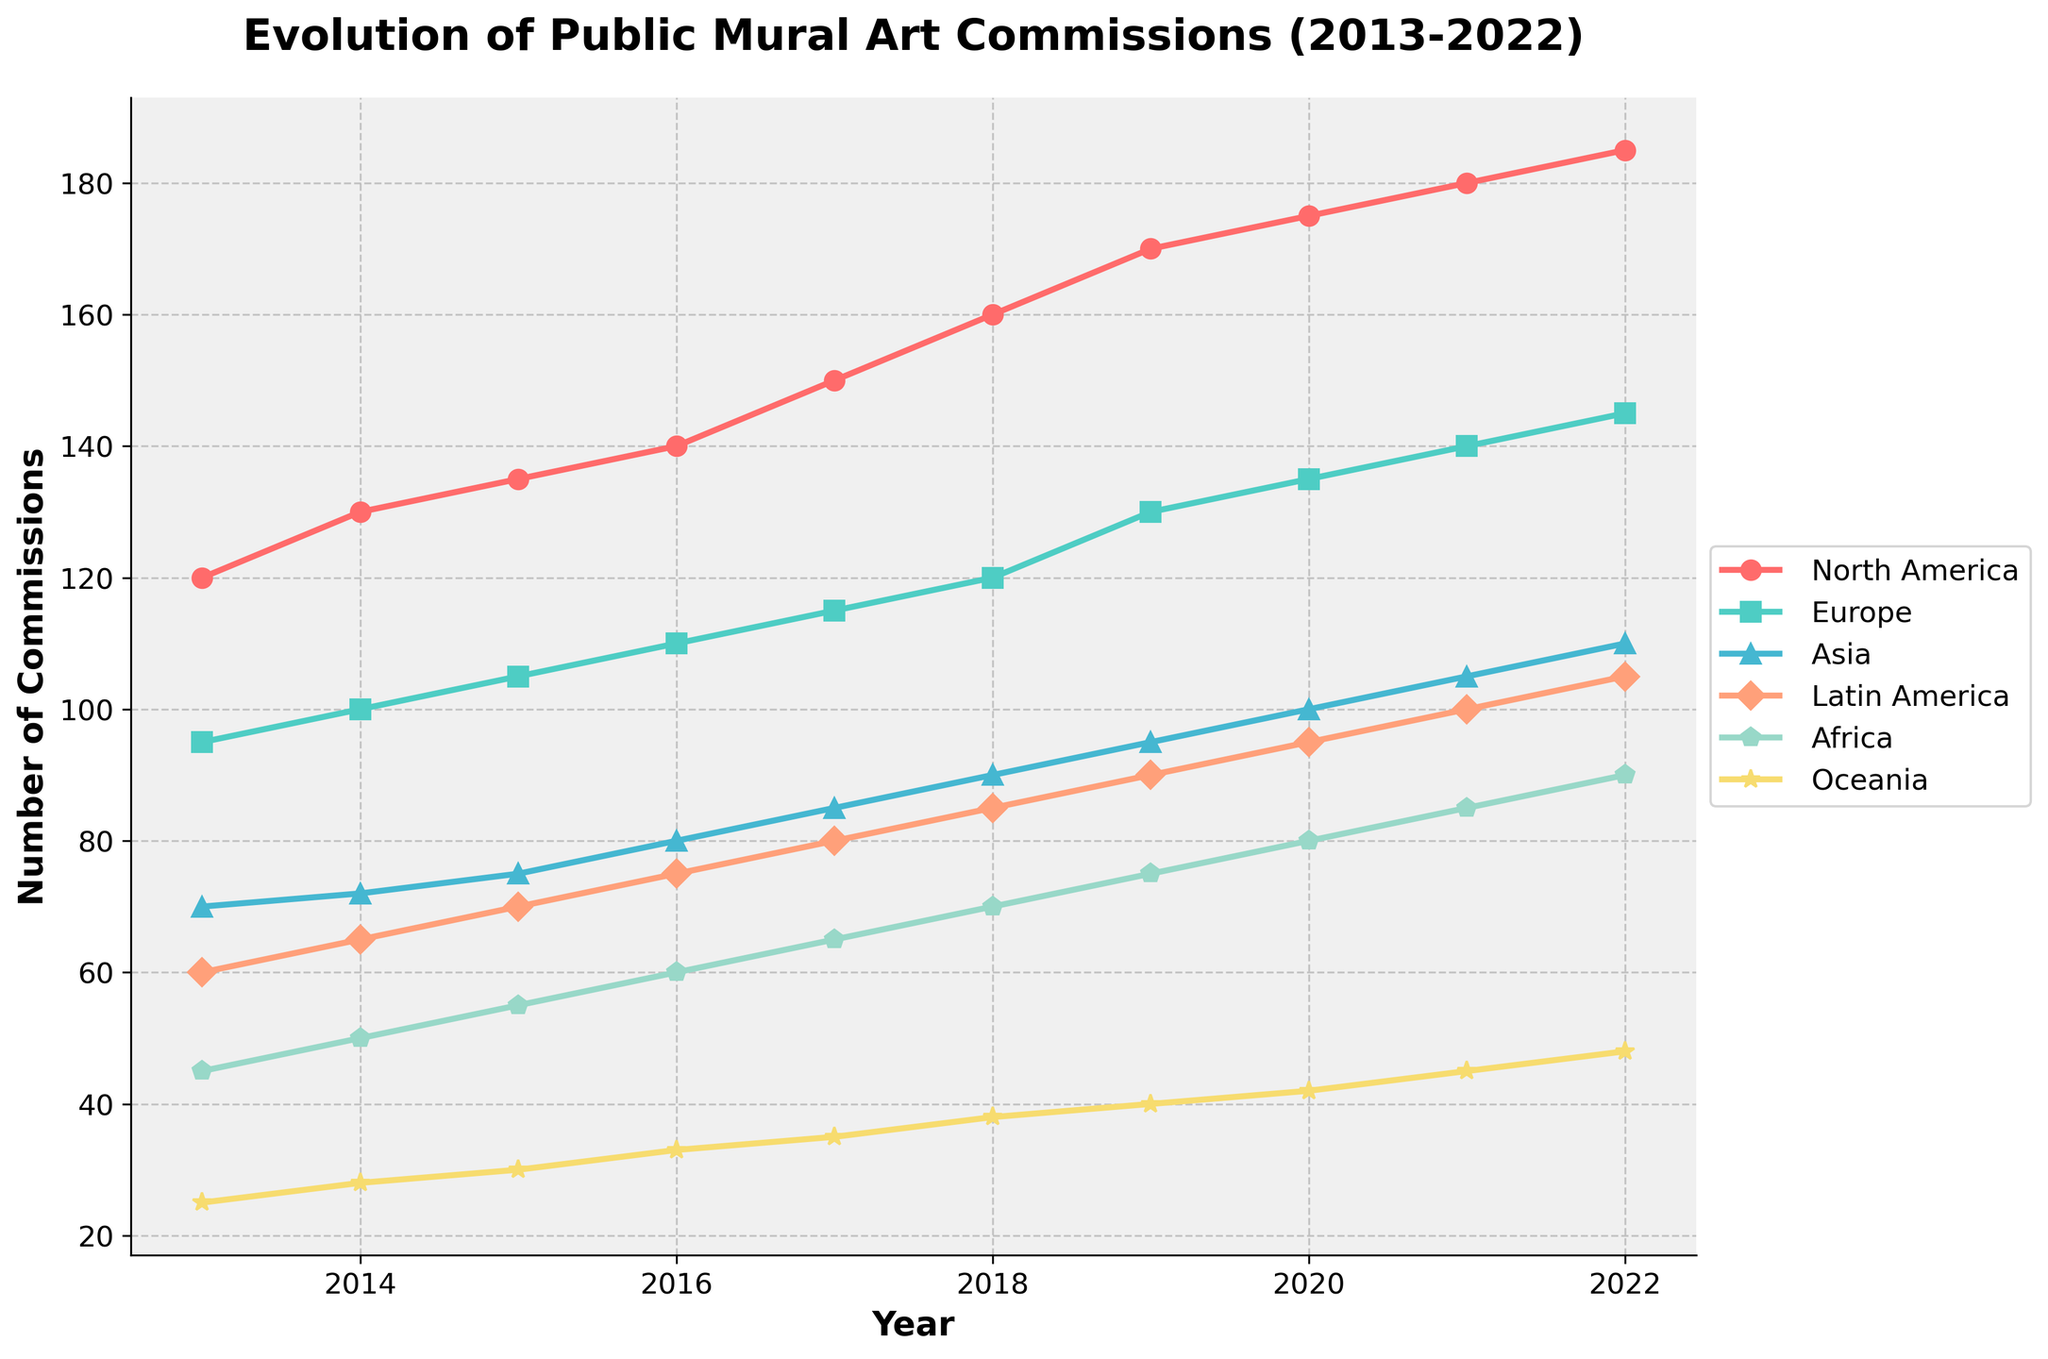what is the title of the plot? The title of the plot is written at the top of the figure. It reads "Evolution of Public Mural Art Commissions (2013-2022)".
Answer: Evolution of Public Mural Art Commissions (2013-2022) what regions are included in the plot? The regions included in the plot are listed in the legend on the right-hand side of the figure. They are North America, Europe, Asia, Latin America, Africa, and Oceania.
Answer: North America, Europe, Asia, Latin America, Africa, Oceania which region had the highest number of commissions in 2022? By looking at the rightmost points on the plot for each region, we see that North America has the highest value.
Answer: North America how did the number of commissions in North America change from 2013 to 2022? By comparing the value at the start (2013) and end (2022) of the plot for North America, the number of commissions increased from 120 to 185.
Answer: Increased from 120 to 185 how many data points are there for each region? Each region has one data point per year from 2013 to 2022, making it a total of 10 data points per region.
Answer: 10 what regions showed a monotonic increase in the number of commissions over the decade? A monotonic increase means the number of commissions never decreased year over year. By examining all polylines, we can see that North America, Europe, Asia, Latin America, and Africa showed a consistent increase.
Answer: North America, Europe, Asia, Latin America, Africa which region had the smallest growth in commissions over the decade? We need to compare the differences in the number of commissions from 2013 to 2022 for all regions. Oceania increased from 25 to 48, the smallest growth.
Answer: Oceania what is the trend of the number of mural art commissions in Europe from 2013 to 2022? Examining the line for Europe from left to right, the number of commissions increased steadily from 95 in 2013 to 145 in 2022.
Answer: Increasing trend compare the number of commissions in Asia and Latin America in 2020 Looking at the data points for 2020, Asia had 100 commissions, while Latin America had 95.
Answer: Asia > Latin America which year did Africa see the number of commissions reach 70? By following the line for Africa and identifying the point where it reaches 70, we find that it is in the year 2018.
Answer: 2018 